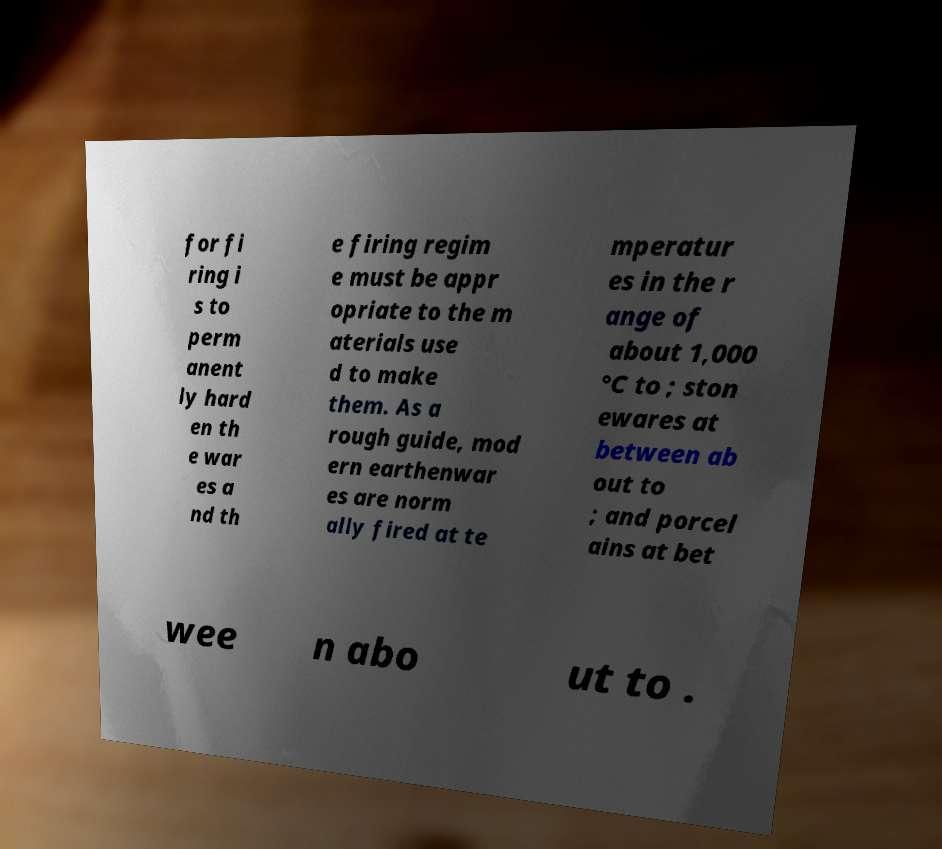Could you extract and type out the text from this image? for fi ring i s to perm anent ly hard en th e war es a nd th e firing regim e must be appr opriate to the m aterials use d to make them. As a rough guide, mod ern earthenwar es are norm ally fired at te mperatur es in the r ange of about 1,000 °C to ; ston ewares at between ab out to ; and porcel ains at bet wee n abo ut to . 